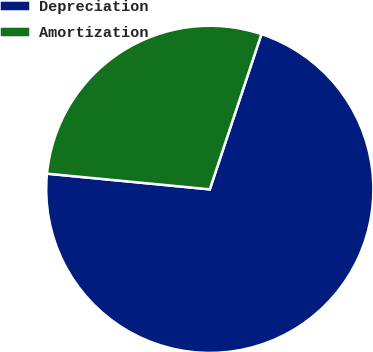Convert chart to OTSL. <chart><loc_0><loc_0><loc_500><loc_500><pie_chart><fcel>Depreciation<fcel>Amortization<nl><fcel>71.42%<fcel>28.58%<nl></chart> 